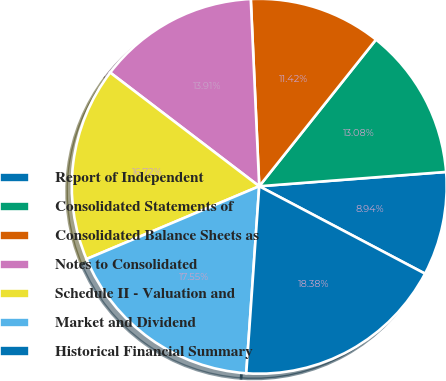<chart> <loc_0><loc_0><loc_500><loc_500><pie_chart><fcel>Report of Independent<fcel>Consolidated Statements of<fcel>Consolidated Balance Sheets as<fcel>Notes to Consolidated<fcel>Schedule II - Valuation and<fcel>Market and Dividend<fcel>Historical Financial Summary<nl><fcel>8.94%<fcel>13.08%<fcel>11.42%<fcel>13.91%<fcel>16.72%<fcel>17.55%<fcel>18.38%<nl></chart> 